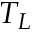Convert formula to latex. <formula><loc_0><loc_0><loc_500><loc_500>T _ { L }</formula> 